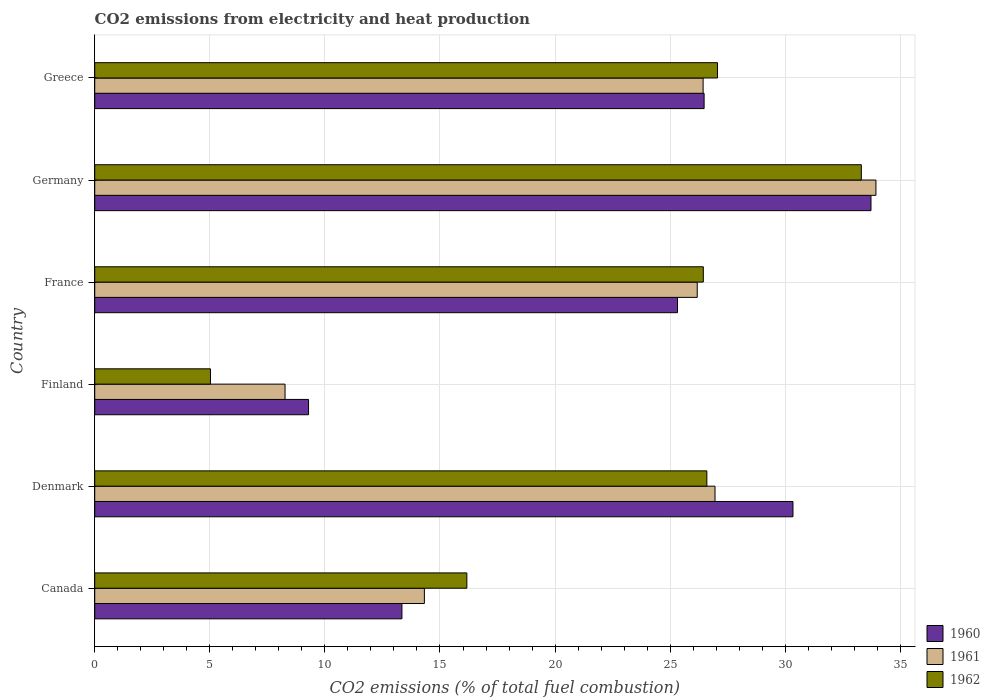How many different coloured bars are there?
Keep it short and to the point. 3. How many groups of bars are there?
Provide a succinct answer. 6. Are the number of bars per tick equal to the number of legend labels?
Offer a terse response. Yes. In how many cases, is the number of bars for a given country not equal to the number of legend labels?
Keep it short and to the point. 0. What is the amount of CO2 emitted in 1961 in Denmark?
Your answer should be compact. 26.95. Across all countries, what is the maximum amount of CO2 emitted in 1962?
Keep it short and to the point. 33.31. Across all countries, what is the minimum amount of CO2 emitted in 1961?
Ensure brevity in your answer.  8.27. In which country was the amount of CO2 emitted in 1961 maximum?
Give a very brief answer. Germany. What is the total amount of CO2 emitted in 1962 in the graph?
Provide a succinct answer. 134.59. What is the difference between the amount of CO2 emitted in 1961 in Finland and that in Germany?
Give a very brief answer. -25.67. What is the difference between the amount of CO2 emitted in 1962 in Denmark and the amount of CO2 emitted in 1960 in Canada?
Your response must be concise. 13.25. What is the average amount of CO2 emitted in 1962 per country?
Make the answer very short. 22.43. What is the difference between the amount of CO2 emitted in 1960 and amount of CO2 emitted in 1962 in Greece?
Your answer should be very brief. -0.58. What is the ratio of the amount of CO2 emitted in 1962 in Denmark to that in Greece?
Offer a terse response. 0.98. What is the difference between the highest and the second highest amount of CO2 emitted in 1960?
Offer a very short reply. 3.39. What is the difference between the highest and the lowest amount of CO2 emitted in 1961?
Your answer should be compact. 25.67. Is the sum of the amount of CO2 emitted in 1962 in Canada and Germany greater than the maximum amount of CO2 emitted in 1960 across all countries?
Your answer should be very brief. Yes. Is it the case that in every country, the sum of the amount of CO2 emitted in 1962 and amount of CO2 emitted in 1960 is greater than the amount of CO2 emitted in 1961?
Your answer should be compact. Yes. Are all the bars in the graph horizontal?
Make the answer very short. Yes. What is the difference between two consecutive major ticks on the X-axis?
Offer a terse response. 5. Does the graph contain any zero values?
Make the answer very short. No. Does the graph contain grids?
Keep it short and to the point. Yes. How many legend labels are there?
Your response must be concise. 3. What is the title of the graph?
Offer a very short reply. CO2 emissions from electricity and heat production. Does "1973" appear as one of the legend labels in the graph?
Offer a terse response. No. What is the label or title of the X-axis?
Your answer should be very brief. CO2 emissions (% of total fuel combustion). What is the CO2 emissions (% of total fuel combustion) in 1960 in Canada?
Your response must be concise. 13.35. What is the CO2 emissions (% of total fuel combustion) of 1961 in Canada?
Your response must be concise. 14.32. What is the CO2 emissions (% of total fuel combustion) of 1962 in Canada?
Give a very brief answer. 16.17. What is the CO2 emissions (% of total fuel combustion) in 1960 in Denmark?
Offer a terse response. 30.34. What is the CO2 emissions (% of total fuel combustion) of 1961 in Denmark?
Your response must be concise. 26.95. What is the CO2 emissions (% of total fuel combustion) of 1962 in Denmark?
Your response must be concise. 26.59. What is the CO2 emissions (% of total fuel combustion) of 1960 in Finland?
Provide a short and direct response. 9.29. What is the CO2 emissions (% of total fuel combustion) of 1961 in Finland?
Your response must be concise. 8.27. What is the CO2 emissions (% of total fuel combustion) of 1962 in Finland?
Ensure brevity in your answer.  5.03. What is the CO2 emissions (% of total fuel combustion) of 1960 in France?
Offer a terse response. 25.32. What is the CO2 emissions (% of total fuel combustion) in 1961 in France?
Keep it short and to the point. 26.18. What is the CO2 emissions (% of total fuel combustion) in 1962 in France?
Your answer should be compact. 26.44. What is the CO2 emissions (% of total fuel combustion) of 1960 in Germany?
Offer a terse response. 33.72. What is the CO2 emissions (% of total fuel combustion) of 1961 in Germany?
Make the answer very short. 33.94. What is the CO2 emissions (% of total fuel combustion) of 1962 in Germany?
Give a very brief answer. 33.31. What is the CO2 emissions (% of total fuel combustion) in 1960 in Greece?
Your answer should be very brief. 26.47. What is the CO2 emissions (% of total fuel combustion) in 1961 in Greece?
Ensure brevity in your answer.  26.43. What is the CO2 emissions (% of total fuel combustion) in 1962 in Greece?
Your answer should be compact. 27.06. Across all countries, what is the maximum CO2 emissions (% of total fuel combustion) in 1960?
Your answer should be very brief. 33.72. Across all countries, what is the maximum CO2 emissions (% of total fuel combustion) of 1961?
Provide a succinct answer. 33.94. Across all countries, what is the maximum CO2 emissions (% of total fuel combustion) in 1962?
Ensure brevity in your answer.  33.31. Across all countries, what is the minimum CO2 emissions (% of total fuel combustion) of 1960?
Your answer should be very brief. 9.29. Across all countries, what is the minimum CO2 emissions (% of total fuel combustion) in 1961?
Your answer should be compact. 8.27. Across all countries, what is the minimum CO2 emissions (% of total fuel combustion) in 1962?
Make the answer very short. 5.03. What is the total CO2 emissions (% of total fuel combustion) of 1960 in the graph?
Provide a succinct answer. 138.49. What is the total CO2 emissions (% of total fuel combustion) of 1961 in the graph?
Provide a short and direct response. 136.09. What is the total CO2 emissions (% of total fuel combustion) in 1962 in the graph?
Your response must be concise. 134.59. What is the difference between the CO2 emissions (% of total fuel combustion) of 1960 in Canada and that in Denmark?
Offer a very short reply. -16.99. What is the difference between the CO2 emissions (% of total fuel combustion) of 1961 in Canada and that in Denmark?
Make the answer very short. -12.63. What is the difference between the CO2 emissions (% of total fuel combustion) in 1962 in Canada and that in Denmark?
Your answer should be compact. -10.43. What is the difference between the CO2 emissions (% of total fuel combustion) in 1960 in Canada and that in Finland?
Provide a succinct answer. 4.06. What is the difference between the CO2 emissions (% of total fuel combustion) of 1961 in Canada and that in Finland?
Keep it short and to the point. 6.05. What is the difference between the CO2 emissions (% of total fuel combustion) in 1962 in Canada and that in Finland?
Offer a terse response. 11.14. What is the difference between the CO2 emissions (% of total fuel combustion) of 1960 in Canada and that in France?
Make the answer very short. -11.97. What is the difference between the CO2 emissions (% of total fuel combustion) in 1961 in Canada and that in France?
Make the answer very short. -11.85. What is the difference between the CO2 emissions (% of total fuel combustion) in 1962 in Canada and that in France?
Give a very brief answer. -10.27. What is the difference between the CO2 emissions (% of total fuel combustion) in 1960 in Canada and that in Germany?
Make the answer very short. -20.38. What is the difference between the CO2 emissions (% of total fuel combustion) in 1961 in Canada and that in Germany?
Give a very brief answer. -19.62. What is the difference between the CO2 emissions (% of total fuel combustion) of 1962 in Canada and that in Germany?
Ensure brevity in your answer.  -17.14. What is the difference between the CO2 emissions (% of total fuel combustion) in 1960 in Canada and that in Greece?
Offer a very short reply. -13.13. What is the difference between the CO2 emissions (% of total fuel combustion) of 1961 in Canada and that in Greece?
Ensure brevity in your answer.  -12.11. What is the difference between the CO2 emissions (% of total fuel combustion) in 1962 in Canada and that in Greece?
Your answer should be compact. -10.89. What is the difference between the CO2 emissions (% of total fuel combustion) in 1960 in Denmark and that in Finland?
Ensure brevity in your answer.  21.05. What is the difference between the CO2 emissions (% of total fuel combustion) of 1961 in Denmark and that in Finland?
Give a very brief answer. 18.68. What is the difference between the CO2 emissions (% of total fuel combustion) in 1962 in Denmark and that in Finland?
Offer a very short reply. 21.57. What is the difference between the CO2 emissions (% of total fuel combustion) in 1960 in Denmark and that in France?
Offer a very short reply. 5.02. What is the difference between the CO2 emissions (% of total fuel combustion) in 1961 in Denmark and that in France?
Give a very brief answer. 0.77. What is the difference between the CO2 emissions (% of total fuel combustion) in 1962 in Denmark and that in France?
Give a very brief answer. 0.15. What is the difference between the CO2 emissions (% of total fuel combustion) in 1960 in Denmark and that in Germany?
Your answer should be very brief. -3.39. What is the difference between the CO2 emissions (% of total fuel combustion) of 1961 in Denmark and that in Germany?
Make the answer very short. -6.99. What is the difference between the CO2 emissions (% of total fuel combustion) of 1962 in Denmark and that in Germany?
Offer a very short reply. -6.71. What is the difference between the CO2 emissions (% of total fuel combustion) of 1960 in Denmark and that in Greece?
Provide a short and direct response. 3.86. What is the difference between the CO2 emissions (% of total fuel combustion) in 1961 in Denmark and that in Greece?
Offer a very short reply. 0.52. What is the difference between the CO2 emissions (% of total fuel combustion) in 1962 in Denmark and that in Greece?
Make the answer very short. -0.46. What is the difference between the CO2 emissions (% of total fuel combustion) in 1960 in Finland and that in France?
Provide a succinct answer. -16.03. What is the difference between the CO2 emissions (% of total fuel combustion) of 1961 in Finland and that in France?
Your answer should be very brief. -17.91. What is the difference between the CO2 emissions (% of total fuel combustion) in 1962 in Finland and that in France?
Provide a short and direct response. -21.41. What is the difference between the CO2 emissions (% of total fuel combustion) of 1960 in Finland and that in Germany?
Make the answer very short. -24.44. What is the difference between the CO2 emissions (% of total fuel combustion) in 1961 in Finland and that in Germany?
Ensure brevity in your answer.  -25.67. What is the difference between the CO2 emissions (% of total fuel combustion) in 1962 in Finland and that in Germany?
Give a very brief answer. -28.28. What is the difference between the CO2 emissions (% of total fuel combustion) of 1960 in Finland and that in Greece?
Ensure brevity in your answer.  -17.19. What is the difference between the CO2 emissions (% of total fuel combustion) in 1961 in Finland and that in Greece?
Offer a terse response. -18.16. What is the difference between the CO2 emissions (% of total fuel combustion) in 1962 in Finland and that in Greece?
Offer a terse response. -22.03. What is the difference between the CO2 emissions (% of total fuel combustion) in 1960 in France and that in Germany?
Your answer should be compact. -8.41. What is the difference between the CO2 emissions (% of total fuel combustion) of 1961 in France and that in Germany?
Make the answer very short. -7.76. What is the difference between the CO2 emissions (% of total fuel combustion) in 1962 in France and that in Germany?
Your answer should be compact. -6.87. What is the difference between the CO2 emissions (% of total fuel combustion) in 1960 in France and that in Greece?
Offer a terse response. -1.16. What is the difference between the CO2 emissions (% of total fuel combustion) in 1961 in France and that in Greece?
Ensure brevity in your answer.  -0.26. What is the difference between the CO2 emissions (% of total fuel combustion) of 1962 in France and that in Greece?
Provide a short and direct response. -0.62. What is the difference between the CO2 emissions (% of total fuel combustion) of 1960 in Germany and that in Greece?
Keep it short and to the point. 7.25. What is the difference between the CO2 emissions (% of total fuel combustion) in 1961 in Germany and that in Greece?
Keep it short and to the point. 7.51. What is the difference between the CO2 emissions (% of total fuel combustion) in 1962 in Germany and that in Greece?
Offer a very short reply. 6.25. What is the difference between the CO2 emissions (% of total fuel combustion) in 1960 in Canada and the CO2 emissions (% of total fuel combustion) in 1961 in Denmark?
Make the answer very short. -13.6. What is the difference between the CO2 emissions (% of total fuel combustion) in 1960 in Canada and the CO2 emissions (% of total fuel combustion) in 1962 in Denmark?
Your answer should be very brief. -13.25. What is the difference between the CO2 emissions (% of total fuel combustion) in 1961 in Canada and the CO2 emissions (% of total fuel combustion) in 1962 in Denmark?
Your answer should be compact. -12.27. What is the difference between the CO2 emissions (% of total fuel combustion) in 1960 in Canada and the CO2 emissions (% of total fuel combustion) in 1961 in Finland?
Provide a succinct answer. 5.08. What is the difference between the CO2 emissions (% of total fuel combustion) of 1960 in Canada and the CO2 emissions (% of total fuel combustion) of 1962 in Finland?
Make the answer very short. 8.32. What is the difference between the CO2 emissions (% of total fuel combustion) in 1961 in Canada and the CO2 emissions (% of total fuel combustion) in 1962 in Finland?
Make the answer very short. 9.29. What is the difference between the CO2 emissions (% of total fuel combustion) of 1960 in Canada and the CO2 emissions (% of total fuel combustion) of 1961 in France?
Keep it short and to the point. -12.83. What is the difference between the CO2 emissions (% of total fuel combustion) of 1960 in Canada and the CO2 emissions (% of total fuel combustion) of 1962 in France?
Provide a succinct answer. -13.09. What is the difference between the CO2 emissions (% of total fuel combustion) of 1961 in Canada and the CO2 emissions (% of total fuel combustion) of 1962 in France?
Keep it short and to the point. -12.12. What is the difference between the CO2 emissions (% of total fuel combustion) in 1960 in Canada and the CO2 emissions (% of total fuel combustion) in 1961 in Germany?
Make the answer very short. -20.59. What is the difference between the CO2 emissions (% of total fuel combustion) in 1960 in Canada and the CO2 emissions (% of total fuel combustion) in 1962 in Germany?
Provide a short and direct response. -19.96. What is the difference between the CO2 emissions (% of total fuel combustion) in 1961 in Canada and the CO2 emissions (% of total fuel combustion) in 1962 in Germany?
Offer a very short reply. -18.98. What is the difference between the CO2 emissions (% of total fuel combustion) of 1960 in Canada and the CO2 emissions (% of total fuel combustion) of 1961 in Greece?
Make the answer very short. -13.08. What is the difference between the CO2 emissions (% of total fuel combustion) of 1960 in Canada and the CO2 emissions (% of total fuel combustion) of 1962 in Greece?
Offer a very short reply. -13.71. What is the difference between the CO2 emissions (% of total fuel combustion) of 1961 in Canada and the CO2 emissions (% of total fuel combustion) of 1962 in Greece?
Give a very brief answer. -12.74. What is the difference between the CO2 emissions (% of total fuel combustion) in 1960 in Denmark and the CO2 emissions (% of total fuel combustion) in 1961 in Finland?
Keep it short and to the point. 22.07. What is the difference between the CO2 emissions (% of total fuel combustion) of 1960 in Denmark and the CO2 emissions (% of total fuel combustion) of 1962 in Finland?
Ensure brevity in your answer.  25.31. What is the difference between the CO2 emissions (% of total fuel combustion) of 1961 in Denmark and the CO2 emissions (% of total fuel combustion) of 1962 in Finland?
Give a very brief answer. 21.92. What is the difference between the CO2 emissions (% of total fuel combustion) in 1960 in Denmark and the CO2 emissions (% of total fuel combustion) in 1961 in France?
Offer a terse response. 4.16. What is the difference between the CO2 emissions (% of total fuel combustion) of 1960 in Denmark and the CO2 emissions (% of total fuel combustion) of 1962 in France?
Keep it short and to the point. 3.9. What is the difference between the CO2 emissions (% of total fuel combustion) in 1961 in Denmark and the CO2 emissions (% of total fuel combustion) in 1962 in France?
Your answer should be compact. 0.51. What is the difference between the CO2 emissions (% of total fuel combustion) of 1960 in Denmark and the CO2 emissions (% of total fuel combustion) of 1961 in Germany?
Give a very brief answer. -3.6. What is the difference between the CO2 emissions (% of total fuel combustion) of 1960 in Denmark and the CO2 emissions (% of total fuel combustion) of 1962 in Germany?
Your answer should be compact. -2.97. What is the difference between the CO2 emissions (% of total fuel combustion) of 1961 in Denmark and the CO2 emissions (% of total fuel combustion) of 1962 in Germany?
Provide a short and direct response. -6.36. What is the difference between the CO2 emissions (% of total fuel combustion) in 1960 in Denmark and the CO2 emissions (% of total fuel combustion) in 1961 in Greece?
Give a very brief answer. 3.9. What is the difference between the CO2 emissions (% of total fuel combustion) in 1960 in Denmark and the CO2 emissions (% of total fuel combustion) in 1962 in Greece?
Offer a terse response. 3.28. What is the difference between the CO2 emissions (% of total fuel combustion) in 1961 in Denmark and the CO2 emissions (% of total fuel combustion) in 1962 in Greece?
Keep it short and to the point. -0.11. What is the difference between the CO2 emissions (% of total fuel combustion) in 1960 in Finland and the CO2 emissions (% of total fuel combustion) in 1961 in France?
Your answer should be very brief. -16.89. What is the difference between the CO2 emissions (% of total fuel combustion) in 1960 in Finland and the CO2 emissions (% of total fuel combustion) in 1962 in France?
Your answer should be very brief. -17.15. What is the difference between the CO2 emissions (% of total fuel combustion) of 1961 in Finland and the CO2 emissions (% of total fuel combustion) of 1962 in France?
Offer a very short reply. -18.17. What is the difference between the CO2 emissions (% of total fuel combustion) of 1960 in Finland and the CO2 emissions (% of total fuel combustion) of 1961 in Germany?
Give a very brief answer. -24.65. What is the difference between the CO2 emissions (% of total fuel combustion) in 1960 in Finland and the CO2 emissions (% of total fuel combustion) in 1962 in Germany?
Offer a terse response. -24.02. What is the difference between the CO2 emissions (% of total fuel combustion) in 1961 in Finland and the CO2 emissions (% of total fuel combustion) in 1962 in Germany?
Provide a succinct answer. -25.04. What is the difference between the CO2 emissions (% of total fuel combustion) in 1960 in Finland and the CO2 emissions (% of total fuel combustion) in 1961 in Greece?
Provide a short and direct response. -17.14. What is the difference between the CO2 emissions (% of total fuel combustion) of 1960 in Finland and the CO2 emissions (% of total fuel combustion) of 1962 in Greece?
Keep it short and to the point. -17.77. What is the difference between the CO2 emissions (% of total fuel combustion) of 1961 in Finland and the CO2 emissions (% of total fuel combustion) of 1962 in Greece?
Ensure brevity in your answer.  -18.79. What is the difference between the CO2 emissions (% of total fuel combustion) in 1960 in France and the CO2 emissions (% of total fuel combustion) in 1961 in Germany?
Your answer should be compact. -8.62. What is the difference between the CO2 emissions (% of total fuel combustion) of 1960 in France and the CO2 emissions (% of total fuel combustion) of 1962 in Germany?
Provide a succinct answer. -7.99. What is the difference between the CO2 emissions (% of total fuel combustion) of 1961 in France and the CO2 emissions (% of total fuel combustion) of 1962 in Germany?
Provide a succinct answer. -7.13. What is the difference between the CO2 emissions (% of total fuel combustion) in 1960 in France and the CO2 emissions (% of total fuel combustion) in 1961 in Greece?
Give a very brief answer. -1.11. What is the difference between the CO2 emissions (% of total fuel combustion) of 1960 in France and the CO2 emissions (% of total fuel combustion) of 1962 in Greece?
Your answer should be very brief. -1.74. What is the difference between the CO2 emissions (% of total fuel combustion) in 1961 in France and the CO2 emissions (% of total fuel combustion) in 1962 in Greece?
Provide a succinct answer. -0.88. What is the difference between the CO2 emissions (% of total fuel combustion) in 1960 in Germany and the CO2 emissions (% of total fuel combustion) in 1961 in Greece?
Provide a succinct answer. 7.29. What is the difference between the CO2 emissions (% of total fuel combustion) in 1960 in Germany and the CO2 emissions (% of total fuel combustion) in 1962 in Greece?
Offer a very short reply. 6.67. What is the difference between the CO2 emissions (% of total fuel combustion) in 1961 in Germany and the CO2 emissions (% of total fuel combustion) in 1962 in Greece?
Your answer should be very brief. 6.88. What is the average CO2 emissions (% of total fuel combustion) of 1960 per country?
Your answer should be very brief. 23.08. What is the average CO2 emissions (% of total fuel combustion) of 1961 per country?
Give a very brief answer. 22.68. What is the average CO2 emissions (% of total fuel combustion) of 1962 per country?
Your response must be concise. 22.43. What is the difference between the CO2 emissions (% of total fuel combustion) in 1960 and CO2 emissions (% of total fuel combustion) in 1961 in Canada?
Provide a short and direct response. -0.98. What is the difference between the CO2 emissions (% of total fuel combustion) in 1960 and CO2 emissions (% of total fuel combustion) in 1962 in Canada?
Provide a succinct answer. -2.82. What is the difference between the CO2 emissions (% of total fuel combustion) in 1961 and CO2 emissions (% of total fuel combustion) in 1962 in Canada?
Offer a very short reply. -1.85. What is the difference between the CO2 emissions (% of total fuel combustion) of 1960 and CO2 emissions (% of total fuel combustion) of 1961 in Denmark?
Give a very brief answer. 3.39. What is the difference between the CO2 emissions (% of total fuel combustion) of 1960 and CO2 emissions (% of total fuel combustion) of 1962 in Denmark?
Make the answer very short. 3.74. What is the difference between the CO2 emissions (% of total fuel combustion) in 1961 and CO2 emissions (% of total fuel combustion) in 1962 in Denmark?
Provide a short and direct response. 0.35. What is the difference between the CO2 emissions (% of total fuel combustion) in 1960 and CO2 emissions (% of total fuel combustion) in 1961 in Finland?
Your answer should be very brief. 1.02. What is the difference between the CO2 emissions (% of total fuel combustion) of 1960 and CO2 emissions (% of total fuel combustion) of 1962 in Finland?
Your answer should be very brief. 4.26. What is the difference between the CO2 emissions (% of total fuel combustion) of 1961 and CO2 emissions (% of total fuel combustion) of 1962 in Finland?
Offer a very short reply. 3.24. What is the difference between the CO2 emissions (% of total fuel combustion) of 1960 and CO2 emissions (% of total fuel combustion) of 1961 in France?
Offer a terse response. -0.86. What is the difference between the CO2 emissions (% of total fuel combustion) in 1960 and CO2 emissions (% of total fuel combustion) in 1962 in France?
Ensure brevity in your answer.  -1.12. What is the difference between the CO2 emissions (% of total fuel combustion) in 1961 and CO2 emissions (% of total fuel combustion) in 1962 in France?
Your response must be concise. -0.26. What is the difference between the CO2 emissions (% of total fuel combustion) of 1960 and CO2 emissions (% of total fuel combustion) of 1961 in Germany?
Make the answer very short. -0.21. What is the difference between the CO2 emissions (% of total fuel combustion) in 1960 and CO2 emissions (% of total fuel combustion) in 1962 in Germany?
Your answer should be very brief. 0.42. What is the difference between the CO2 emissions (% of total fuel combustion) of 1961 and CO2 emissions (% of total fuel combustion) of 1962 in Germany?
Give a very brief answer. 0.63. What is the difference between the CO2 emissions (% of total fuel combustion) of 1960 and CO2 emissions (% of total fuel combustion) of 1961 in Greece?
Offer a very short reply. 0.04. What is the difference between the CO2 emissions (% of total fuel combustion) of 1960 and CO2 emissions (% of total fuel combustion) of 1962 in Greece?
Your answer should be compact. -0.58. What is the difference between the CO2 emissions (% of total fuel combustion) of 1961 and CO2 emissions (% of total fuel combustion) of 1962 in Greece?
Your response must be concise. -0.63. What is the ratio of the CO2 emissions (% of total fuel combustion) in 1960 in Canada to that in Denmark?
Provide a succinct answer. 0.44. What is the ratio of the CO2 emissions (% of total fuel combustion) in 1961 in Canada to that in Denmark?
Ensure brevity in your answer.  0.53. What is the ratio of the CO2 emissions (% of total fuel combustion) in 1962 in Canada to that in Denmark?
Give a very brief answer. 0.61. What is the ratio of the CO2 emissions (% of total fuel combustion) in 1960 in Canada to that in Finland?
Offer a very short reply. 1.44. What is the ratio of the CO2 emissions (% of total fuel combustion) of 1961 in Canada to that in Finland?
Provide a short and direct response. 1.73. What is the ratio of the CO2 emissions (% of total fuel combustion) of 1962 in Canada to that in Finland?
Your response must be concise. 3.22. What is the ratio of the CO2 emissions (% of total fuel combustion) in 1960 in Canada to that in France?
Your answer should be very brief. 0.53. What is the ratio of the CO2 emissions (% of total fuel combustion) of 1961 in Canada to that in France?
Give a very brief answer. 0.55. What is the ratio of the CO2 emissions (% of total fuel combustion) in 1962 in Canada to that in France?
Your answer should be compact. 0.61. What is the ratio of the CO2 emissions (% of total fuel combustion) of 1960 in Canada to that in Germany?
Keep it short and to the point. 0.4. What is the ratio of the CO2 emissions (% of total fuel combustion) in 1961 in Canada to that in Germany?
Keep it short and to the point. 0.42. What is the ratio of the CO2 emissions (% of total fuel combustion) in 1962 in Canada to that in Germany?
Your response must be concise. 0.49. What is the ratio of the CO2 emissions (% of total fuel combustion) in 1960 in Canada to that in Greece?
Your answer should be very brief. 0.5. What is the ratio of the CO2 emissions (% of total fuel combustion) in 1961 in Canada to that in Greece?
Make the answer very short. 0.54. What is the ratio of the CO2 emissions (% of total fuel combustion) of 1962 in Canada to that in Greece?
Give a very brief answer. 0.6. What is the ratio of the CO2 emissions (% of total fuel combustion) of 1960 in Denmark to that in Finland?
Offer a terse response. 3.27. What is the ratio of the CO2 emissions (% of total fuel combustion) of 1961 in Denmark to that in Finland?
Your response must be concise. 3.26. What is the ratio of the CO2 emissions (% of total fuel combustion) in 1962 in Denmark to that in Finland?
Your answer should be very brief. 5.29. What is the ratio of the CO2 emissions (% of total fuel combustion) in 1960 in Denmark to that in France?
Offer a very short reply. 1.2. What is the ratio of the CO2 emissions (% of total fuel combustion) of 1961 in Denmark to that in France?
Your response must be concise. 1.03. What is the ratio of the CO2 emissions (% of total fuel combustion) of 1960 in Denmark to that in Germany?
Your answer should be very brief. 0.9. What is the ratio of the CO2 emissions (% of total fuel combustion) in 1961 in Denmark to that in Germany?
Give a very brief answer. 0.79. What is the ratio of the CO2 emissions (% of total fuel combustion) of 1962 in Denmark to that in Germany?
Ensure brevity in your answer.  0.8. What is the ratio of the CO2 emissions (% of total fuel combustion) of 1960 in Denmark to that in Greece?
Offer a very short reply. 1.15. What is the ratio of the CO2 emissions (% of total fuel combustion) of 1961 in Denmark to that in Greece?
Ensure brevity in your answer.  1.02. What is the ratio of the CO2 emissions (% of total fuel combustion) of 1962 in Denmark to that in Greece?
Provide a succinct answer. 0.98. What is the ratio of the CO2 emissions (% of total fuel combustion) of 1960 in Finland to that in France?
Your answer should be compact. 0.37. What is the ratio of the CO2 emissions (% of total fuel combustion) of 1961 in Finland to that in France?
Give a very brief answer. 0.32. What is the ratio of the CO2 emissions (% of total fuel combustion) of 1962 in Finland to that in France?
Provide a succinct answer. 0.19. What is the ratio of the CO2 emissions (% of total fuel combustion) in 1960 in Finland to that in Germany?
Your response must be concise. 0.28. What is the ratio of the CO2 emissions (% of total fuel combustion) of 1961 in Finland to that in Germany?
Give a very brief answer. 0.24. What is the ratio of the CO2 emissions (% of total fuel combustion) in 1962 in Finland to that in Germany?
Give a very brief answer. 0.15. What is the ratio of the CO2 emissions (% of total fuel combustion) of 1960 in Finland to that in Greece?
Your answer should be compact. 0.35. What is the ratio of the CO2 emissions (% of total fuel combustion) in 1961 in Finland to that in Greece?
Your answer should be very brief. 0.31. What is the ratio of the CO2 emissions (% of total fuel combustion) of 1962 in Finland to that in Greece?
Provide a short and direct response. 0.19. What is the ratio of the CO2 emissions (% of total fuel combustion) of 1960 in France to that in Germany?
Provide a short and direct response. 0.75. What is the ratio of the CO2 emissions (% of total fuel combustion) in 1961 in France to that in Germany?
Ensure brevity in your answer.  0.77. What is the ratio of the CO2 emissions (% of total fuel combustion) of 1962 in France to that in Germany?
Make the answer very short. 0.79. What is the ratio of the CO2 emissions (% of total fuel combustion) of 1960 in France to that in Greece?
Your answer should be compact. 0.96. What is the ratio of the CO2 emissions (% of total fuel combustion) of 1961 in France to that in Greece?
Offer a terse response. 0.99. What is the ratio of the CO2 emissions (% of total fuel combustion) of 1962 in France to that in Greece?
Give a very brief answer. 0.98. What is the ratio of the CO2 emissions (% of total fuel combustion) of 1960 in Germany to that in Greece?
Provide a succinct answer. 1.27. What is the ratio of the CO2 emissions (% of total fuel combustion) of 1961 in Germany to that in Greece?
Offer a very short reply. 1.28. What is the ratio of the CO2 emissions (% of total fuel combustion) of 1962 in Germany to that in Greece?
Provide a short and direct response. 1.23. What is the difference between the highest and the second highest CO2 emissions (% of total fuel combustion) in 1960?
Your response must be concise. 3.39. What is the difference between the highest and the second highest CO2 emissions (% of total fuel combustion) in 1961?
Keep it short and to the point. 6.99. What is the difference between the highest and the second highest CO2 emissions (% of total fuel combustion) in 1962?
Provide a succinct answer. 6.25. What is the difference between the highest and the lowest CO2 emissions (% of total fuel combustion) in 1960?
Provide a succinct answer. 24.44. What is the difference between the highest and the lowest CO2 emissions (% of total fuel combustion) of 1961?
Make the answer very short. 25.67. What is the difference between the highest and the lowest CO2 emissions (% of total fuel combustion) of 1962?
Give a very brief answer. 28.28. 